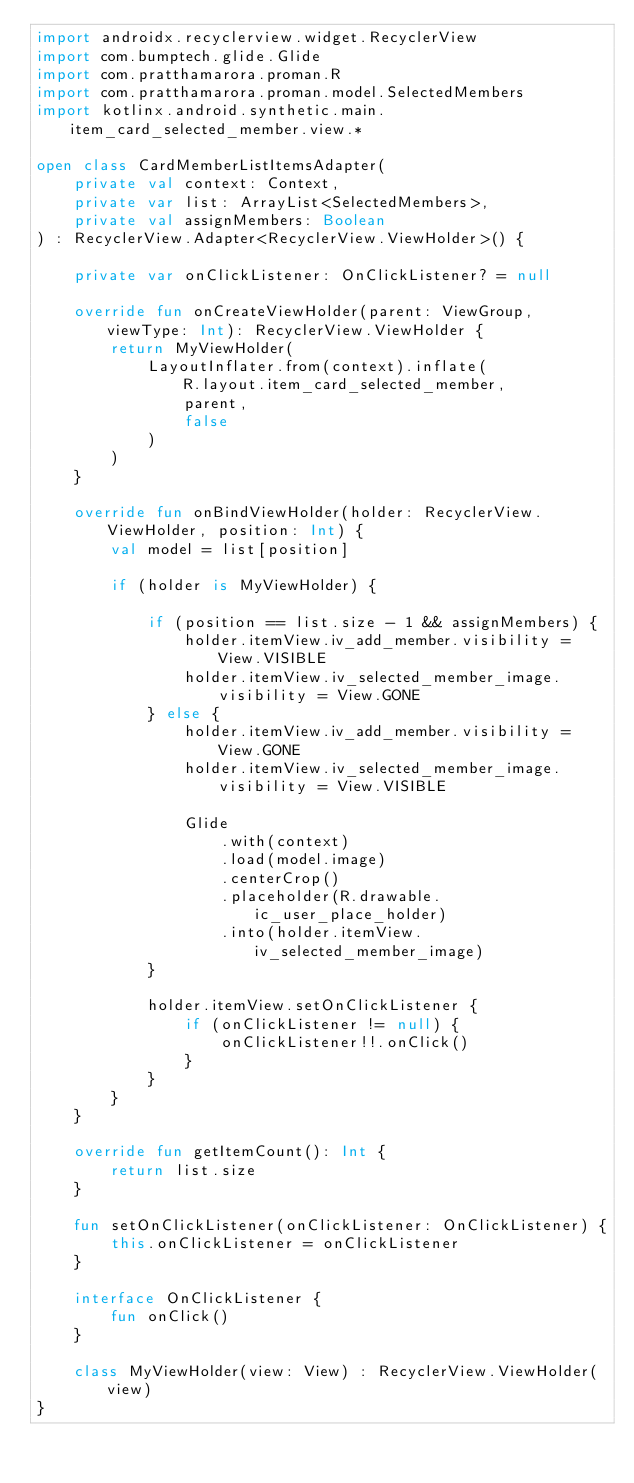Convert code to text. <code><loc_0><loc_0><loc_500><loc_500><_Kotlin_>import androidx.recyclerview.widget.RecyclerView
import com.bumptech.glide.Glide
import com.pratthamarora.proman.R
import com.pratthamarora.proman.model.SelectedMembers
import kotlinx.android.synthetic.main.item_card_selected_member.view.*

open class CardMemberListItemsAdapter(
    private val context: Context,
    private var list: ArrayList<SelectedMembers>,
    private val assignMembers: Boolean
) : RecyclerView.Adapter<RecyclerView.ViewHolder>() {

    private var onClickListener: OnClickListener? = null

    override fun onCreateViewHolder(parent: ViewGroup, viewType: Int): RecyclerView.ViewHolder {
        return MyViewHolder(
            LayoutInflater.from(context).inflate(
                R.layout.item_card_selected_member,
                parent,
                false
            )
        )
    }

    override fun onBindViewHolder(holder: RecyclerView.ViewHolder, position: Int) {
        val model = list[position]

        if (holder is MyViewHolder) {

            if (position == list.size - 1 && assignMembers) {
                holder.itemView.iv_add_member.visibility = View.VISIBLE
                holder.itemView.iv_selected_member_image.visibility = View.GONE
            } else {
                holder.itemView.iv_add_member.visibility = View.GONE
                holder.itemView.iv_selected_member_image.visibility = View.VISIBLE

                Glide
                    .with(context)
                    .load(model.image)
                    .centerCrop()
                    .placeholder(R.drawable.ic_user_place_holder)
                    .into(holder.itemView.iv_selected_member_image)
            }

            holder.itemView.setOnClickListener {
                if (onClickListener != null) {
                    onClickListener!!.onClick()
                }
            }
        }
    }

    override fun getItemCount(): Int {
        return list.size
    }

    fun setOnClickListener(onClickListener: OnClickListener) {
        this.onClickListener = onClickListener
    }

    interface OnClickListener {
        fun onClick()
    }

    class MyViewHolder(view: View) : RecyclerView.ViewHolder(view)
}</code> 